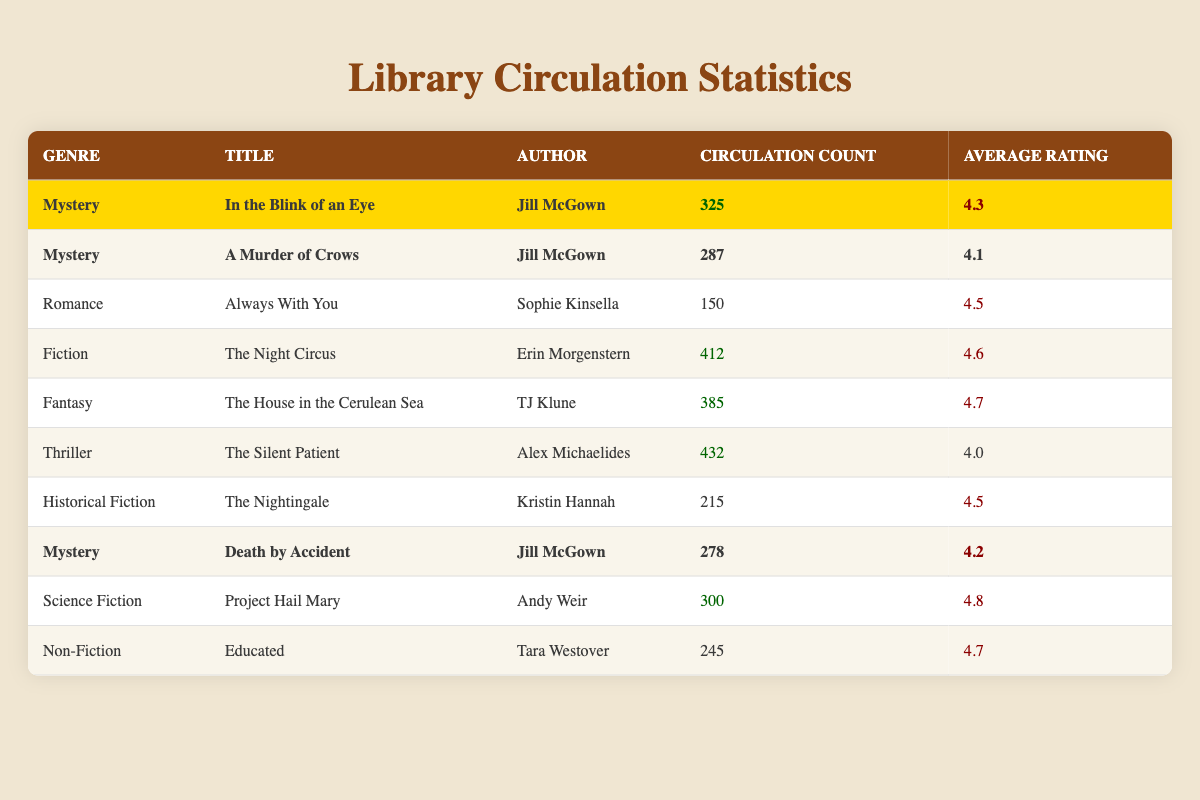What is the most circulated book in the Mystery genre? The most circulated book in the Mystery genre is "In the Blink of an Eye" by Jill McGown with a circulation count of 325. I determined this by comparing the circulation counts for the two Mystery titles listed: "In the Blink of an Eye" (325) and "A Murder of Crows" (287).
Answer: In the Blink of an Eye Which book has the highest average rating? The book with the highest average rating is "Project Hail Mary" by Andy Weir with an average rating of 4.8. To find this, I scanned each book's average rating and compared them, noting that 4.8 is the highest value.
Answer: Project Hail Mary How many titles does Jill McGown have in the Mystery genre? Jill McGown has three titles in the Mystery genre: "In the Blink of an Eye", "A Murder of Crows", and "Death by Accident". I counted the occurrences of Jill McGown's books listed under the Mystery genre in the table.
Answer: 3 What is the total circulation count for all Mystery novels combined? The total circulation count for all Mystery novels is 890, calculated by summing the circulation counts: 325 (In the Blink of an Eye) + 287 (A Murder of Crows) + 278 (Death by Accident) = 890.
Answer: 890 Is the circulation count of "The Night Circus" higher than "Always With You"? Yes, "The Night Circus" has a circulation count of 412, which is higher than "Always With You" with a count of 150. I found these values in the circulation count column for each respective book.
Answer: Yes What is the average circulation count for the Fiction genre? The average circulation count for the Fiction genre is 412, since there is only one book listed, "The Night Circus", with a circulation count of 412; thus, the average is the same as the single entry.
Answer: 412 Which genre has the most circulated book? The genre with the most circulated book is Thriller, as "The Silent Patient" has the highest circulation count of 432 among all genres. I verified this by checking circulation counts across all genres.
Answer: Thriller How does the average rating of Fantasy books compare to Romance books? The average rating for Fantasy books is 4.7 (for "The House in the Cerulean Sea"), while the average rating for Romance books is 4.5 (for "Always With You"). Comparing these ratings, Fantasy has a higher average rating than Romance by 0.2.
Answer: Fantasy is higher What is the total number of books listed in the table? There are a total of 9 books listed in the table. I counted each entry in the table to arrive at the total number.
Answer: 9 Which author has the highest number of titles in the table? Jill McGown has the highest number of titles in the table with three books: "In the Blink of an Eye", "A Murder of Crows", and "Death by Accident". I reviewed the authors listed for each book to count their titles.
Answer: Jill McGown 